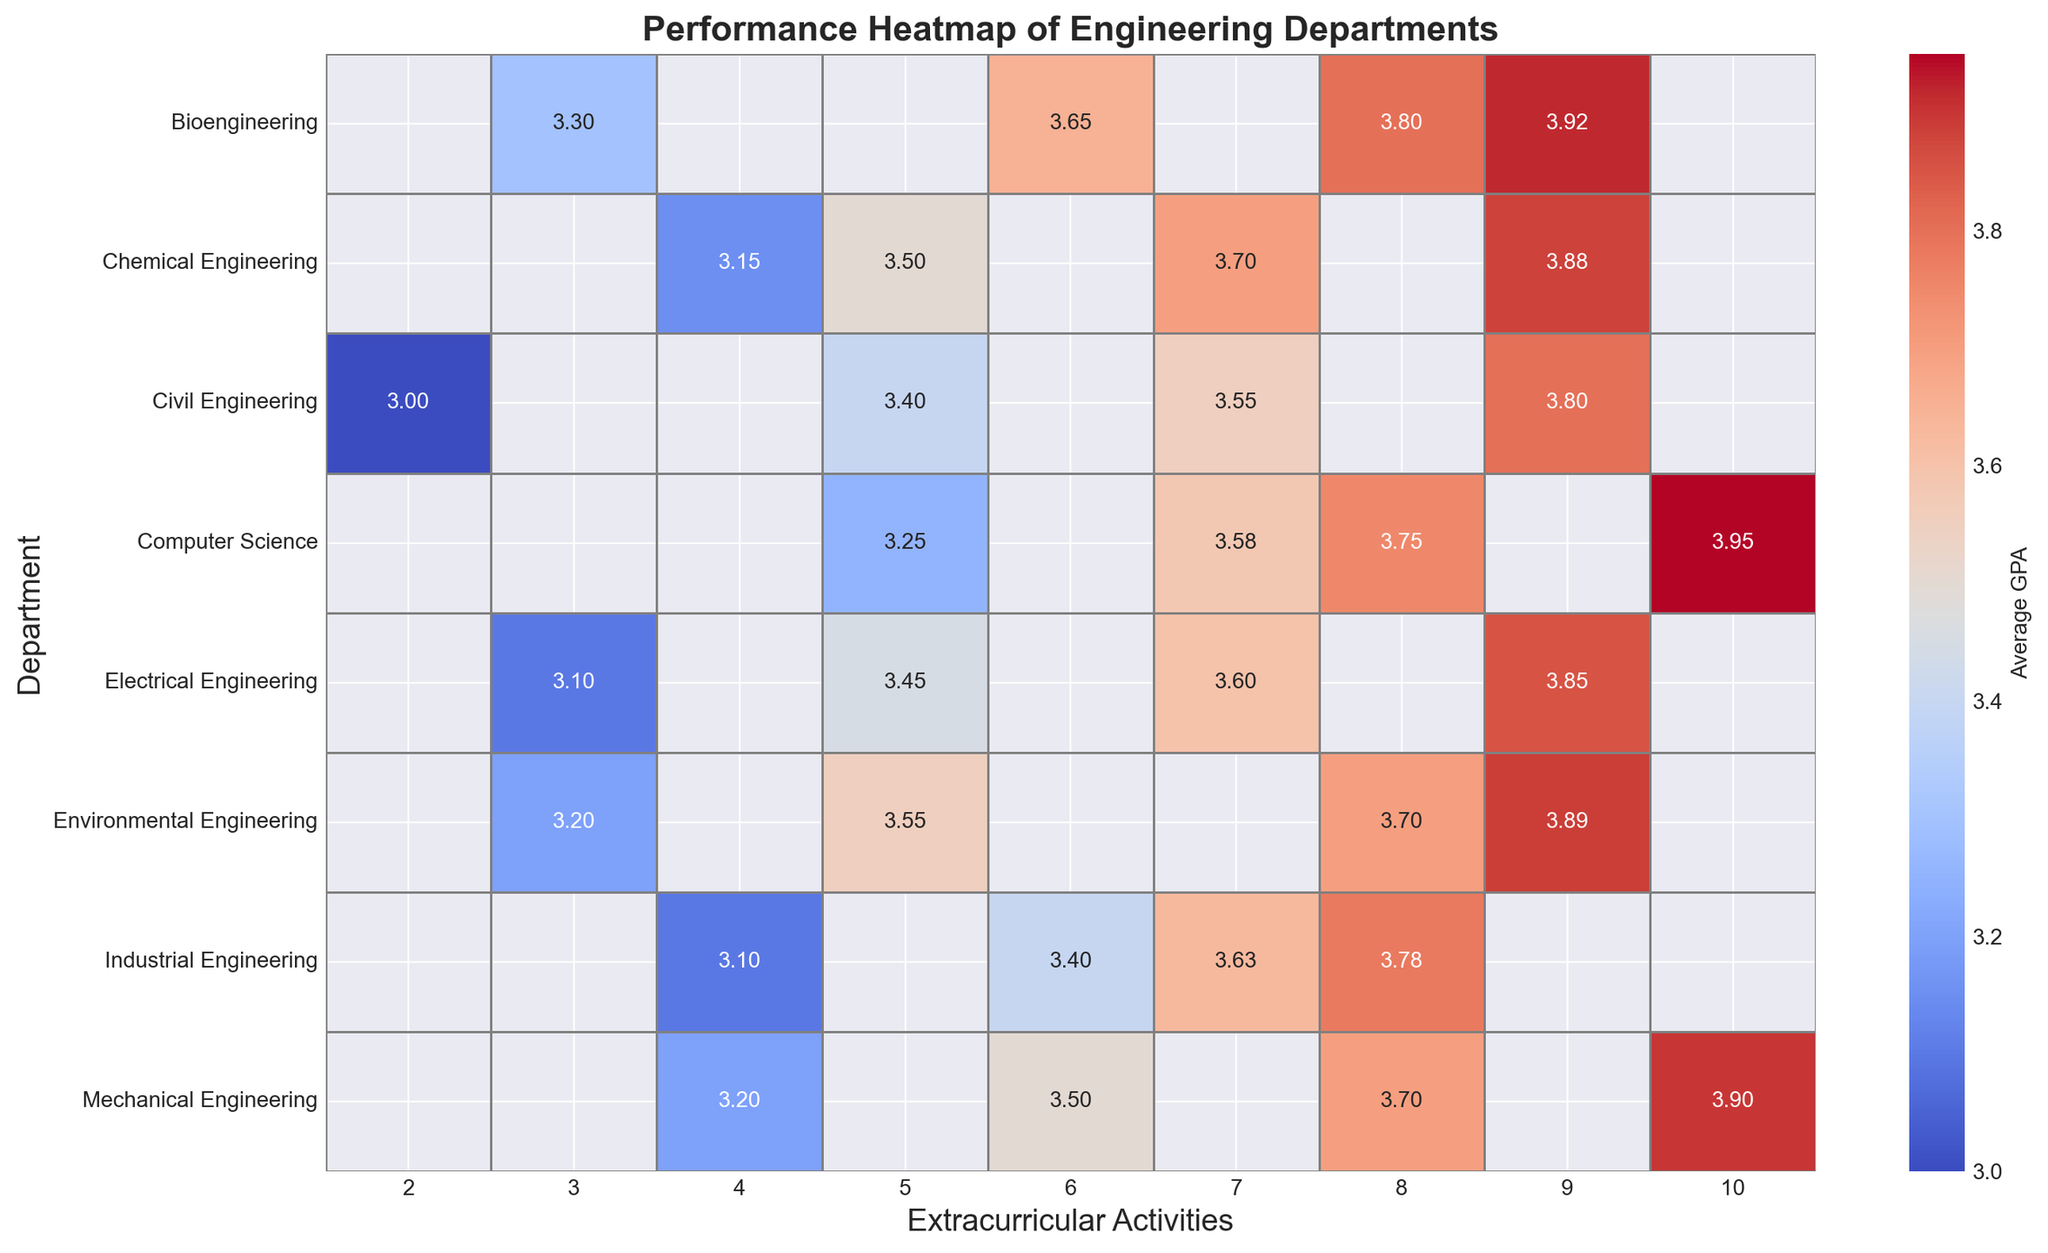What's the average GPA in the Mechanical Engineering department with 8 extracurricular activities? Locate Mechanical Engineering row and the column with 8 extracurricular activities. The annotated GPA value is the average.
Answer: 3.70 Which department has the highest GPA for students with 10 extracurricular activities? Compare the GPA values in the column with 10 extracurricular activities across different departments. The highest GPA is 3.95 in Computer Science.
Answer: Computer Science Is the average GPA for Electrical Engineering students with 5 extracurricular activities higher or lower than Civil Engineering students with the same number of activities? Locate the GPA values for Electrical Engineering and Civil Engineering in the column with 5 extracurricular activities. Compare 3.45 (Electrical Engineering) and 3.40 (Civil Engineering). 3.45 is higher.
Answer: Higher What is the GPA difference between Bioengineering students with 9 extracurricular activities and Environmental Engineering students with the same number of activities? Locate the GPA values in the 9 extracurricular activities column for both Bioengineering (3.92) and Environmental Engineering (3.89). Subtract 3.89 from 3.92. The difference is 0.03.
Answer: 0.03 For departments with students having 6 extracurricular activities, which one has the lowest average GPA? Compare the GPA values in the column with 6 extracurricular activities across all departments. Bioengineering has the lowest GPA of 3.65 in this column.
Answer: Bioengineering What's the average GPA across the departments for students with 4 extracurricular activities? Calculate the sum of GPA values for 4 extracurricular activities across all departments and divide by the number of departments. (Mechanical Engineering 3.20 + Electrical Engineering 3.10 + Civil Engineering 3.00 + Computer Science 3.25 + Chemical Engineering 3.15 + Industrial Engineering 3.10 + Bioengineering 3.30 + Environmental Engineering 3.20) = 25.30. Average = 25.30 / 8 = 3.1625
Answer: 3.16 Which department shows the most consistent GPA across all levels of extracurricular activities? Look at the ranges of GPA values for each department across all levels of extracurricular activities. Computer Science has the least variation, ranging from 3.25 to 3.95.
Answer: Computer Science Do students in Civil Engineering with 7 extracurricular activities have a higher GPA compared to those in Industrial Engineering with the same level of activities? Locate the GPA values for 7 extracurricular activities in Civil Engineering (3.55) and Industrial Engineering (3.63). Compare them. 3.55 is less than 3.63, so the answer is no.
Answer: No Which department has the most consistent GPA with exactly 8 extracurricular activities? Compare GPA values across departments for the column of 8 extracurricular activities. Environmental Engineering, Chemical Engineering, and Bioengineering all have similar values, but Environmental Engineering seems to be most consistent.
Answer: Environmental Engineering What is the GPA range for Chemical Engineering students with extracurricular activities from 4 to 9? Identify GPA values for Chemical Engineering in columns of 4, 5, 7, 8, and 9 extracurricular activities. The GPA values are (4: 3.15, 5: 3.50, 7: 3.70, 8: 3.70, 9: 3.88). The range is highest GPA minus lowest GPA: 3.88 - 3.15 = 0.73
Answer: 0.73 